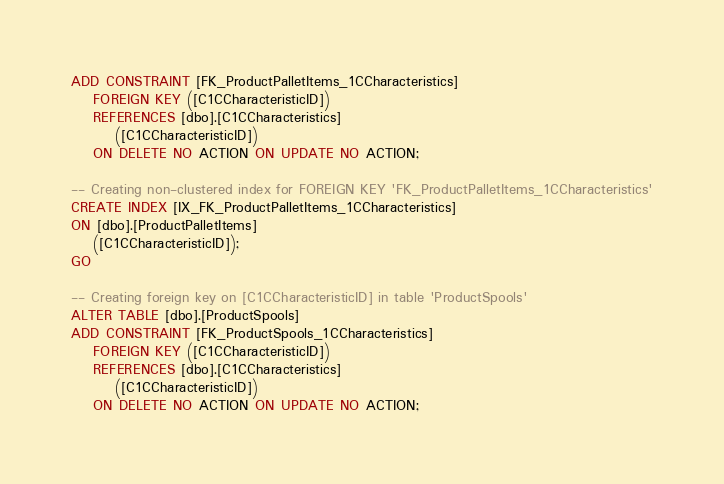<code> <loc_0><loc_0><loc_500><loc_500><_SQL_>ADD CONSTRAINT [FK_ProductPalletItems_1CCharacteristics]
    FOREIGN KEY ([C1CCharacteristicID])
    REFERENCES [dbo].[C1CCharacteristics]
        ([C1CCharacteristicID])
    ON DELETE NO ACTION ON UPDATE NO ACTION;

-- Creating non-clustered index for FOREIGN KEY 'FK_ProductPalletItems_1CCharacteristics'
CREATE INDEX [IX_FK_ProductPalletItems_1CCharacteristics]
ON [dbo].[ProductPalletItems]
    ([C1CCharacteristicID]);
GO

-- Creating foreign key on [C1CCharacteristicID] in table 'ProductSpools'
ALTER TABLE [dbo].[ProductSpools]
ADD CONSTRAINT [FK_ProductSpools_1CCharacteristics]
    FOREIGN KEY ([C1CCharacteristicID])
    REFERENCES [dbo].[C1CCharacteristics]
        ([C1CCharacteristicID])
    ON DELETE NO ACTION ON UPDATE NO ACTION;
</code> 